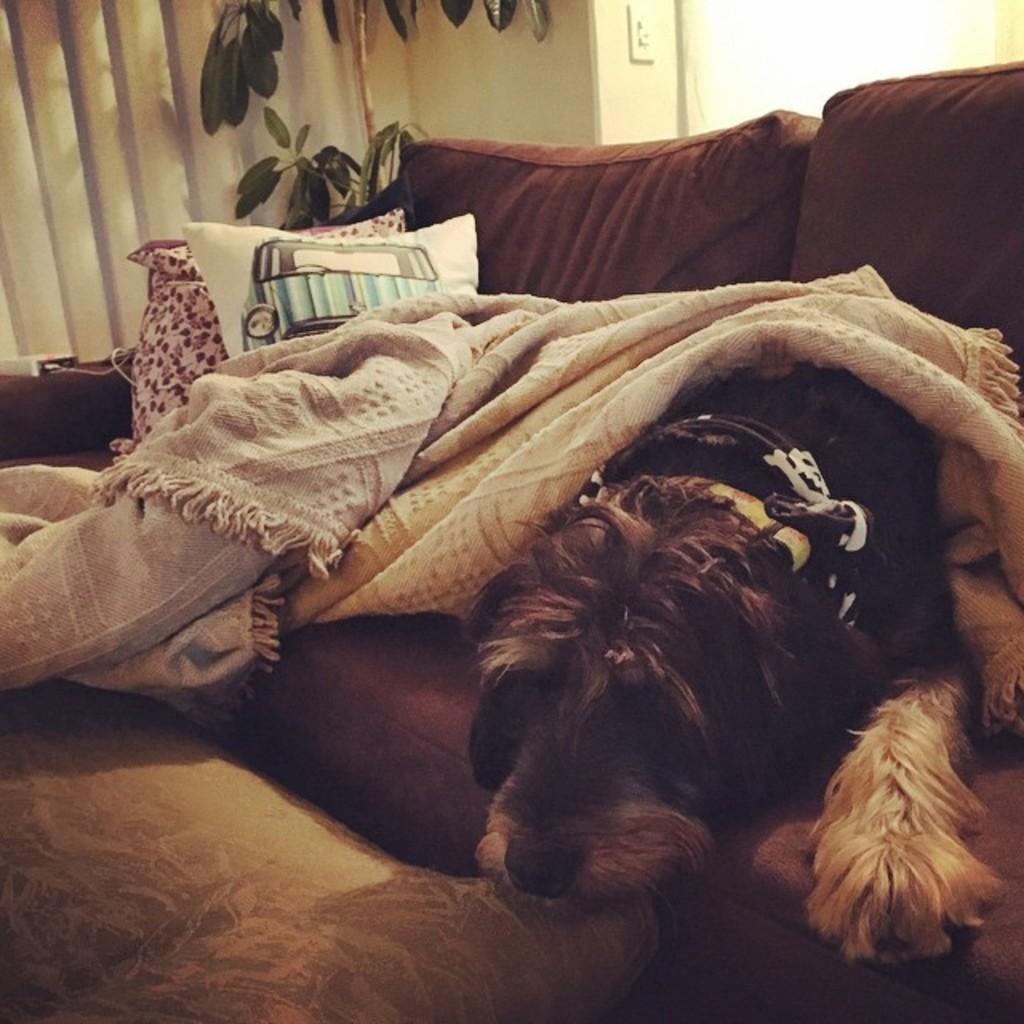Please provide a concise description of this image. In this image I can see the dog and the dog is in brown and cream color. The dog is sitting on the couch and the couch is in brown color and I can see the cream color blanket. Background I can see few leaves in green color and the wall is in cream color. 